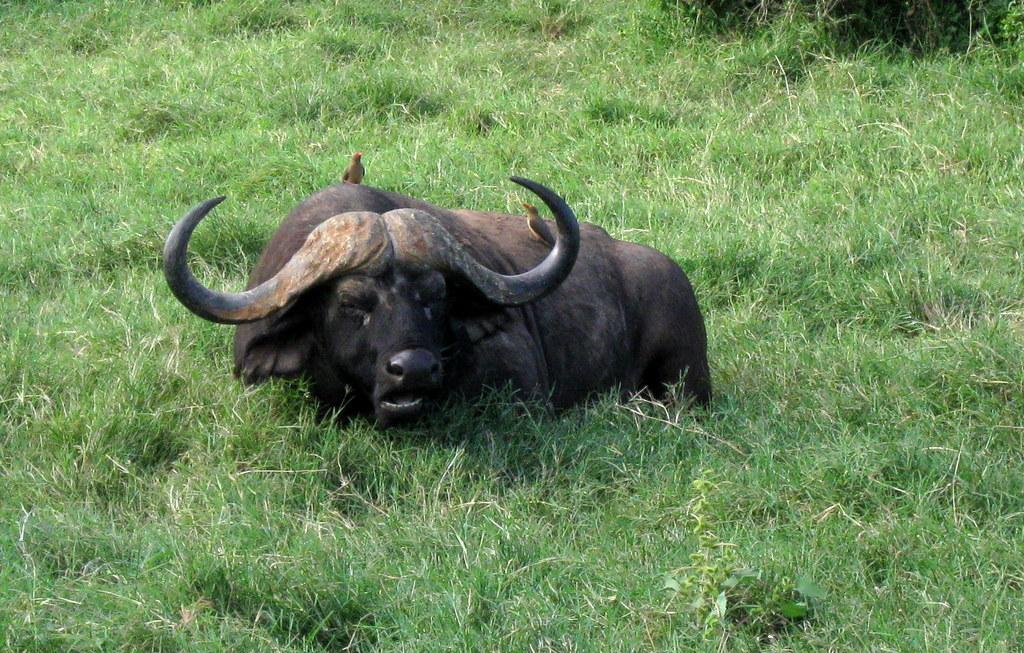What animal is in the foreground of the image? There is a buffalo in the foreground of the image. What is the buffalo doing in the image? The buffalo is sitting on the grass. Are there any other animals present in the image? Yes, there are two birds on the buffalo. What type of cap is the buffalo wearing in the image? There is no cap present on the buffalo in the image. How many stars can be seen on the buffalo's back in the image? There are no stars visible on the buffalo's back in the image. 